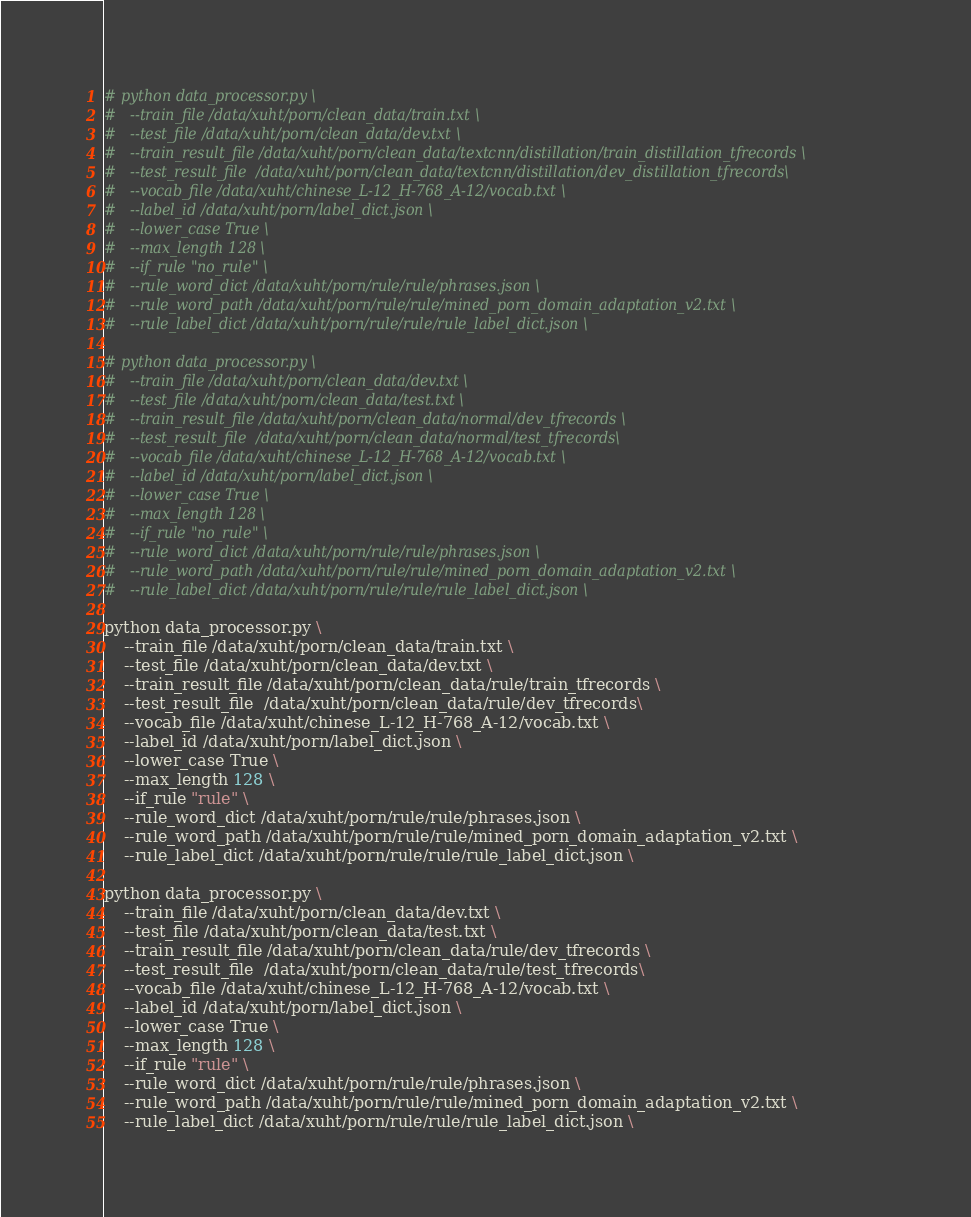<code> <loc_0><loc_0><loc_500><loc_500><_Bash_># python data_processor.py \
# 	--train_file /data/xuht/porn/clean_data/train.txt \
# 	--test_file /data/xuht/porn/clean_data/dev.txt \
# 	--train_result_file /data/xuht/porn/clean_data/textcnn/distillation/train_distillation_tfrecords \
# 	--test_result_file  /data/xuht/porn/clean_data/textcnn/distillation/dev_distillation_tfrecords\
# 	--vocab_file /data/xuht/chinese_L-12_H-768_A-12/vocab.txt \
# 	--label_id /data/xuht/porn/label_dict.json \
# 	--lower_case True \
# 	--max_length 128 \
# 	--if_rule "no_rule" \
# 	--rule_word_dict /data/xuht/porn/rule/rule/phrases.json \
# 	--rule_word_path /data/xuht/porn/rule/rule/mined_porn_domain_adaptation_v2.txt \
# 	--rule_label_dict /data/xuht/porn/rule/rule/rule_label_dict.json \

# python data_processor.py \
# 	--train_file /data/xuht/porn/clean_data/dev.txt \
# 	--test_file /data/xuht/porn/clean_data/test.txt \
# 	--train_result_file /data/xuht/porn/clean_data/normal/dev_tfrecords \
# 	--test_result_file  /data/xuht/porn/clean_data/normal/test_tfrecords\
# 	--vocab_file /data/xuht/chinese_L-12_H-768_A-12/vocab.txt \
# 	--label_id /data/xuht/porn/label_dict.json \
# 	--lower_case True \
# 	--max_length 128 \
# 	--if_rule "no_rule" \
# 	--rule_word_dict /data/xuht/porn/rule/rule/phrases.json \
# 	--rule_word_path /data/xuht/porn/rule/rule/mined_porn_domain_adaptation_v2.txt \
# 	--rule_label_dict /data/xuht/porn/rule/rule/rule_label_dict.json \

python data_processor.py \
	--train_file /data/xuht/porn/clean_data/train.txt \
	--test_file /data/xuht/porn/clean_data/dev.txt \
	--train_result_file /data/xuht/porn/clean_data/rule/train_tfrecords \
	--test_result_file  /data/xuht/porn/clean_data/rule/dev_tfrecords\
	--vocab_file /data/xuht/chinese_L-12_H-768_A-12/vocab.txt \
	--label_id /data/xuht/porn/label_dict.json \
	--lower_case True \
	--max_length 128 \
	--if_rule "rule" \
	--rule_word_dict /data/xuht/porn/rule/rule/phrases.json \
	--rule_word_path /data/xuht/porn/rule/rule/mined_porn_domain_adaptation_v2.txt \
	--rule_label_dict /data/xuht/porn/rule/rule/rule_label_dict.json \

python data_processor.py \
	--train_file /data/xuht/porn/clean_data/dev.txt \
	--test_file /data/xuht/porn/clean_data/test.txt \
	--train_result_file /data/xuht/porn/clean_data/rule/dev_tfrecords \
	--test_result_file  /data/xuht/porn/clean_data/rule/test_tfrecords\
	--vocab_file /data/xuht/chinese_L-12_H-768_A-12/vocab.txt \
	--label_id /data/xuht/porn/label_dict.json \
	--lower_case True \
	--max_length 128 \
	--if_rule "rule" \
	--rule_word_dict /data/xuht/porn/rule/rule/phrases.json \
	--rule_word_path /data/xuht/porn/rule/rule/mined_porn_domain_adaptation_v2.txt \
	--rule_label_dict /data/xuht/porn/rule/rule/rule_label_dict.json \
</code> 